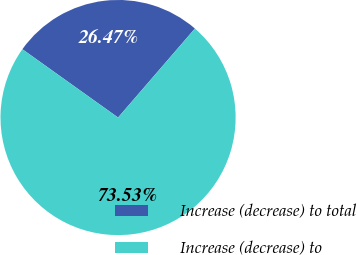Convert chart. <chart><loc_0><loc_0><loc_500><loc_500><pie_chart><fcel>Increase (decrease) to total<fcel>Increase (decrease) to<nl><fcel>26.47%<fcel>73.53%<nl></chart> 